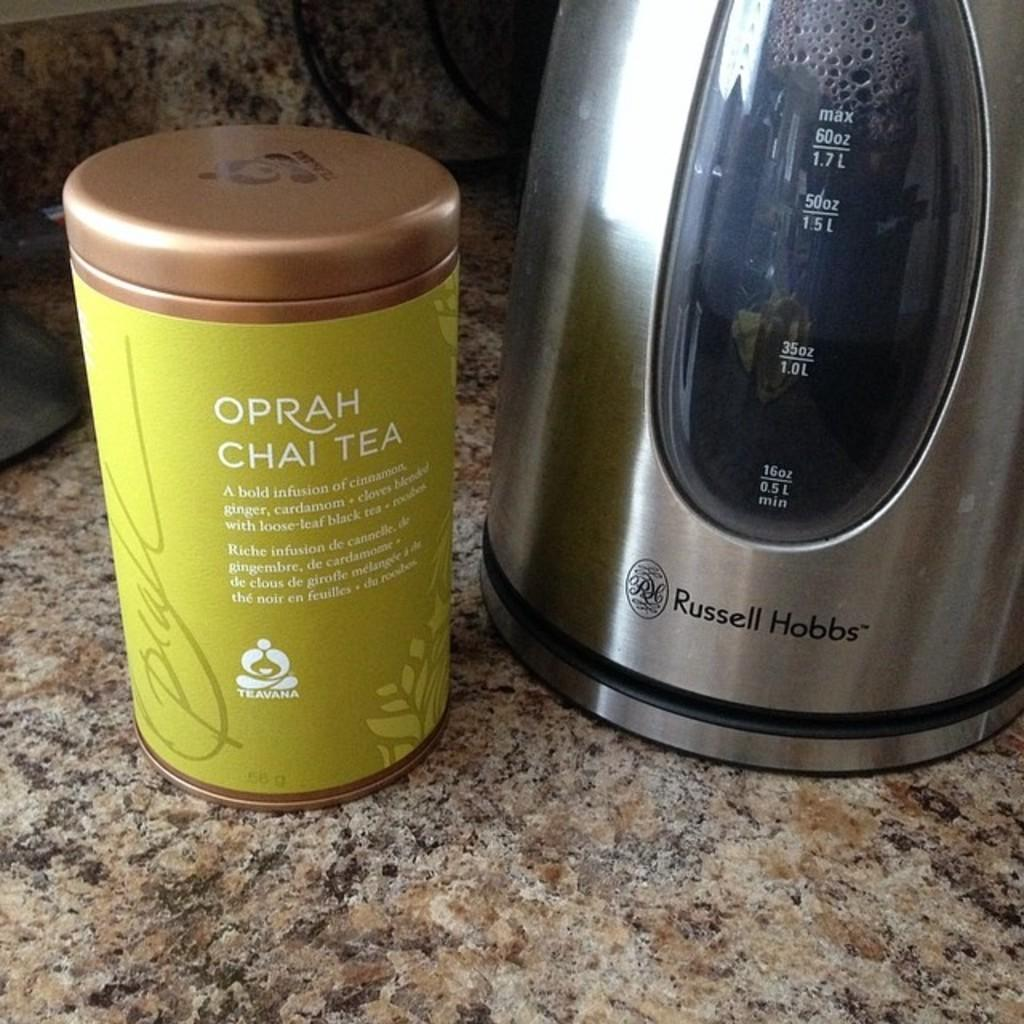<image>
Render a clear and concise summary of the photo. Container of Oprah's Chai Tea and a Russel Hobbs tea kettle to make it in. 